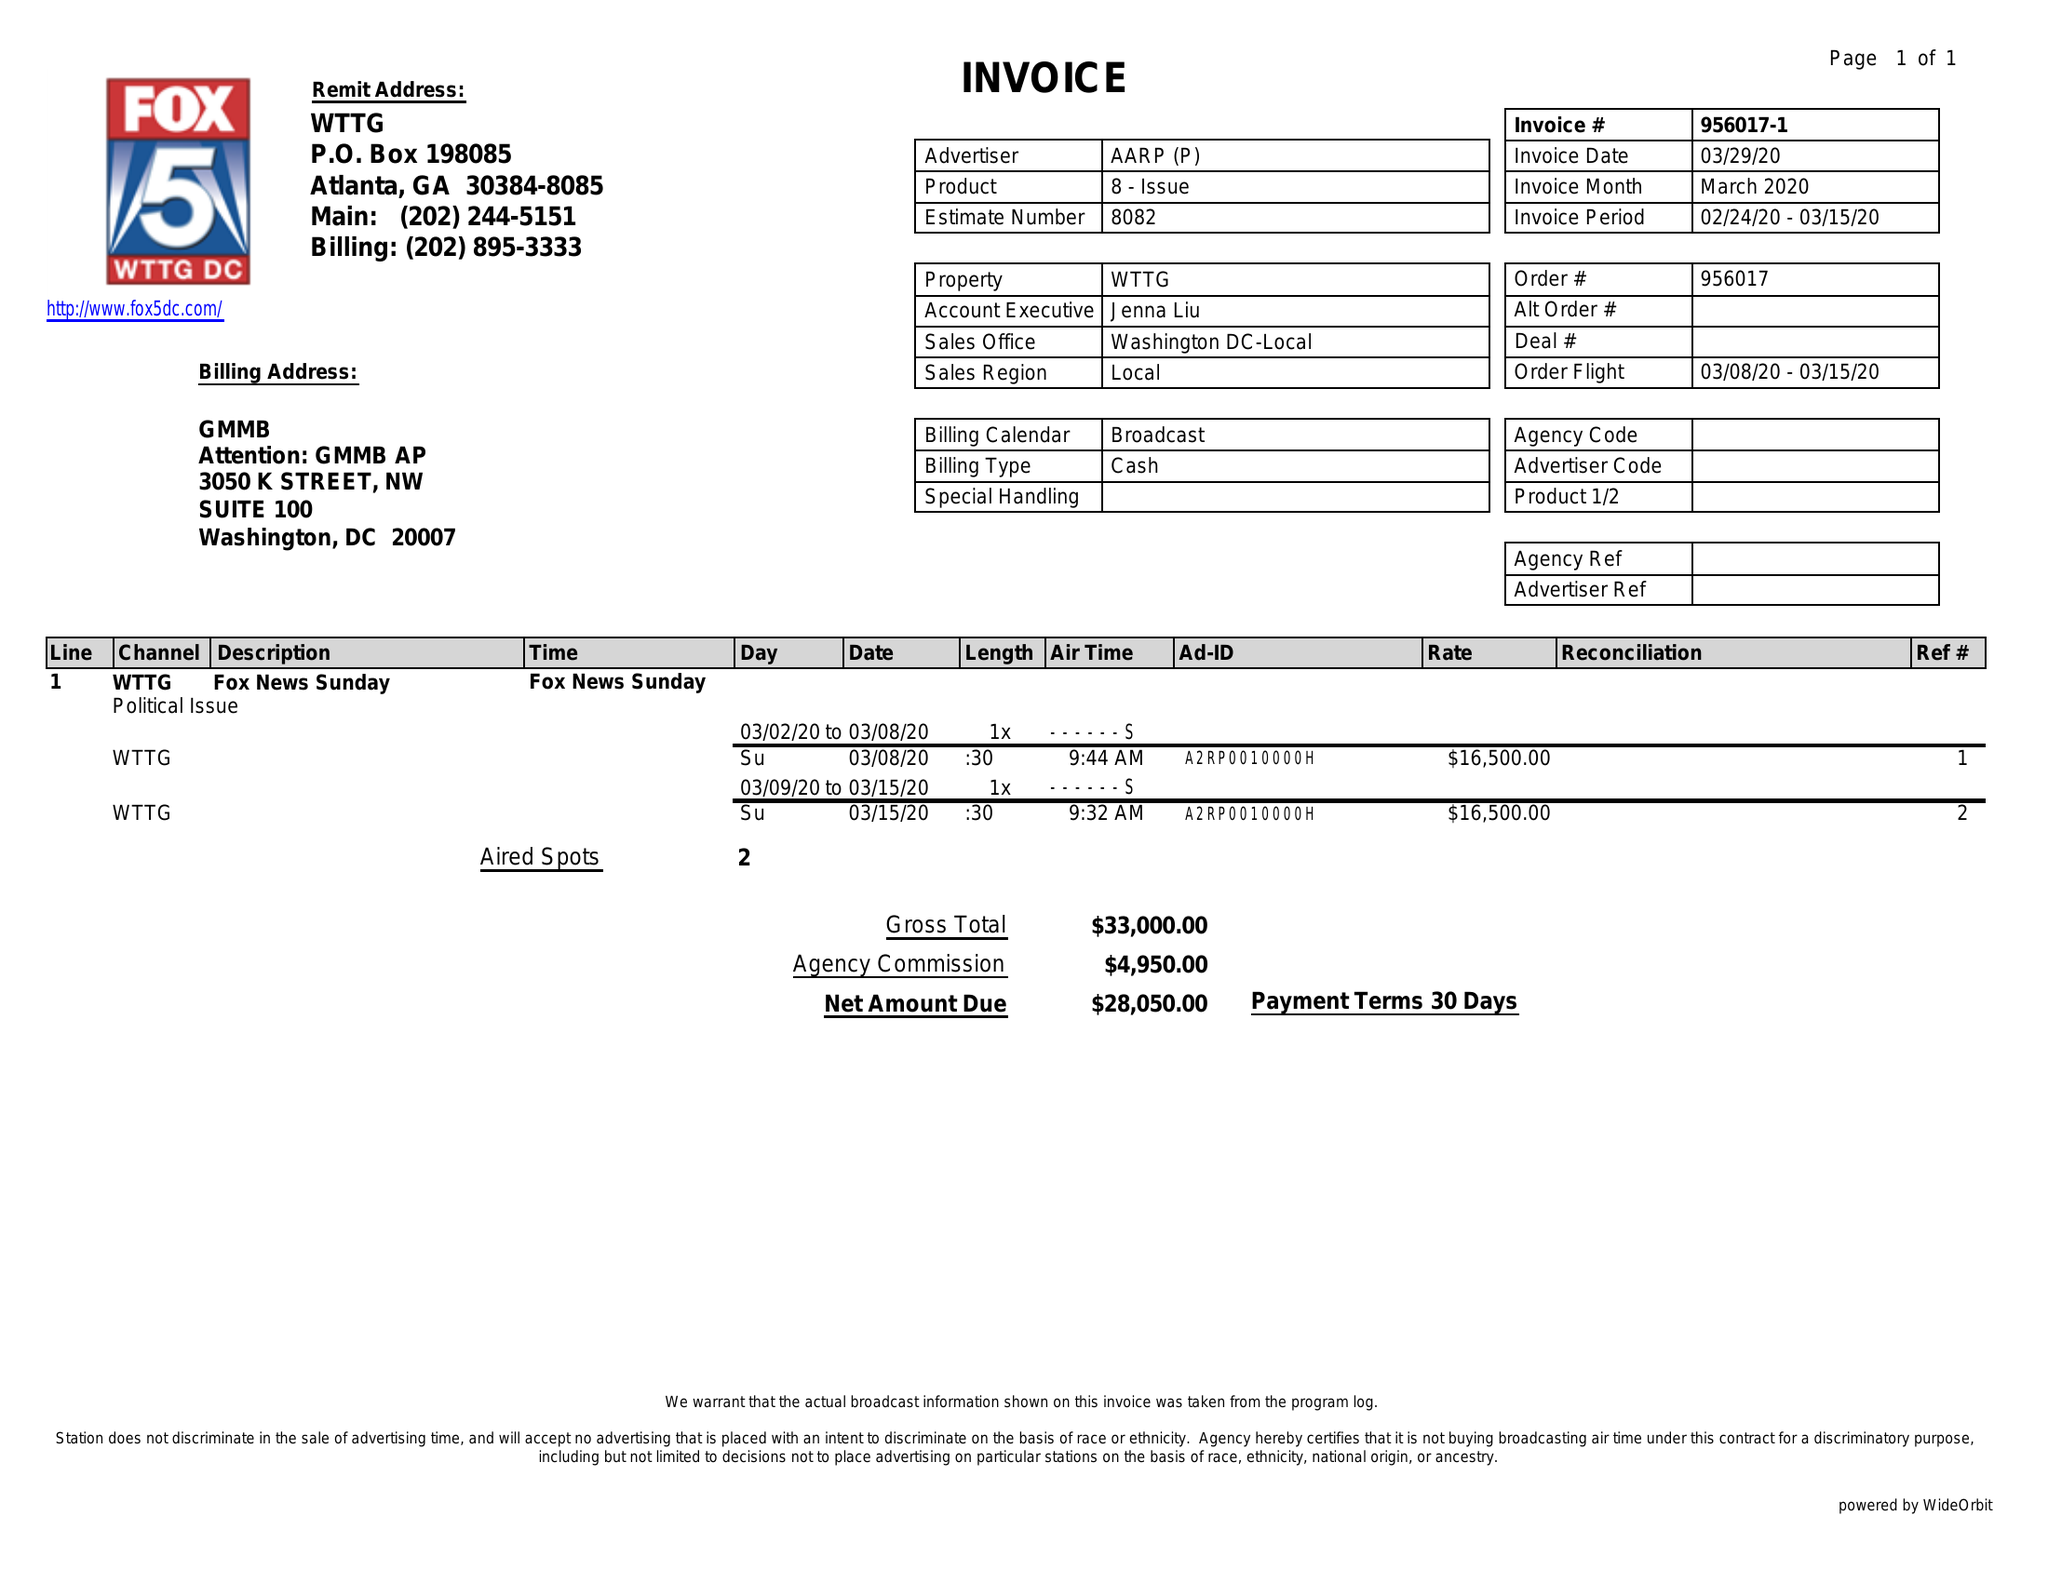What is the value for the flight_to?
Answer the question using a single word or phrase. 03/15/20 